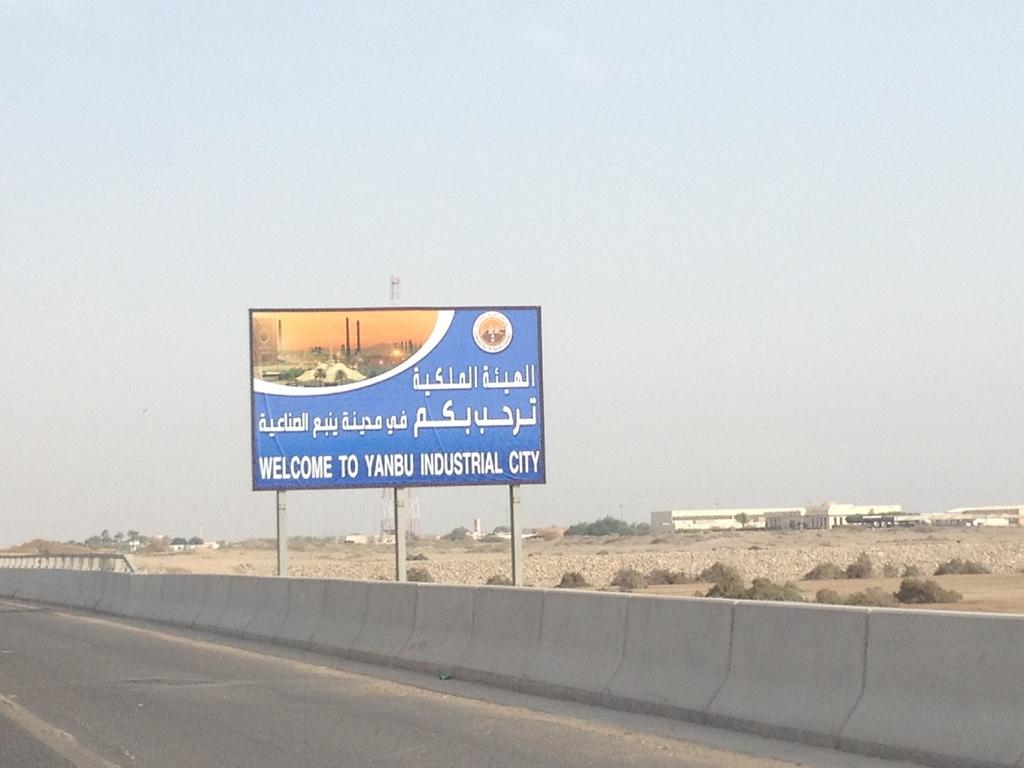<image>
Give a short and clear explanation of the subsequent image. a large road sign welcoming drivers to yanbu industrial city. 